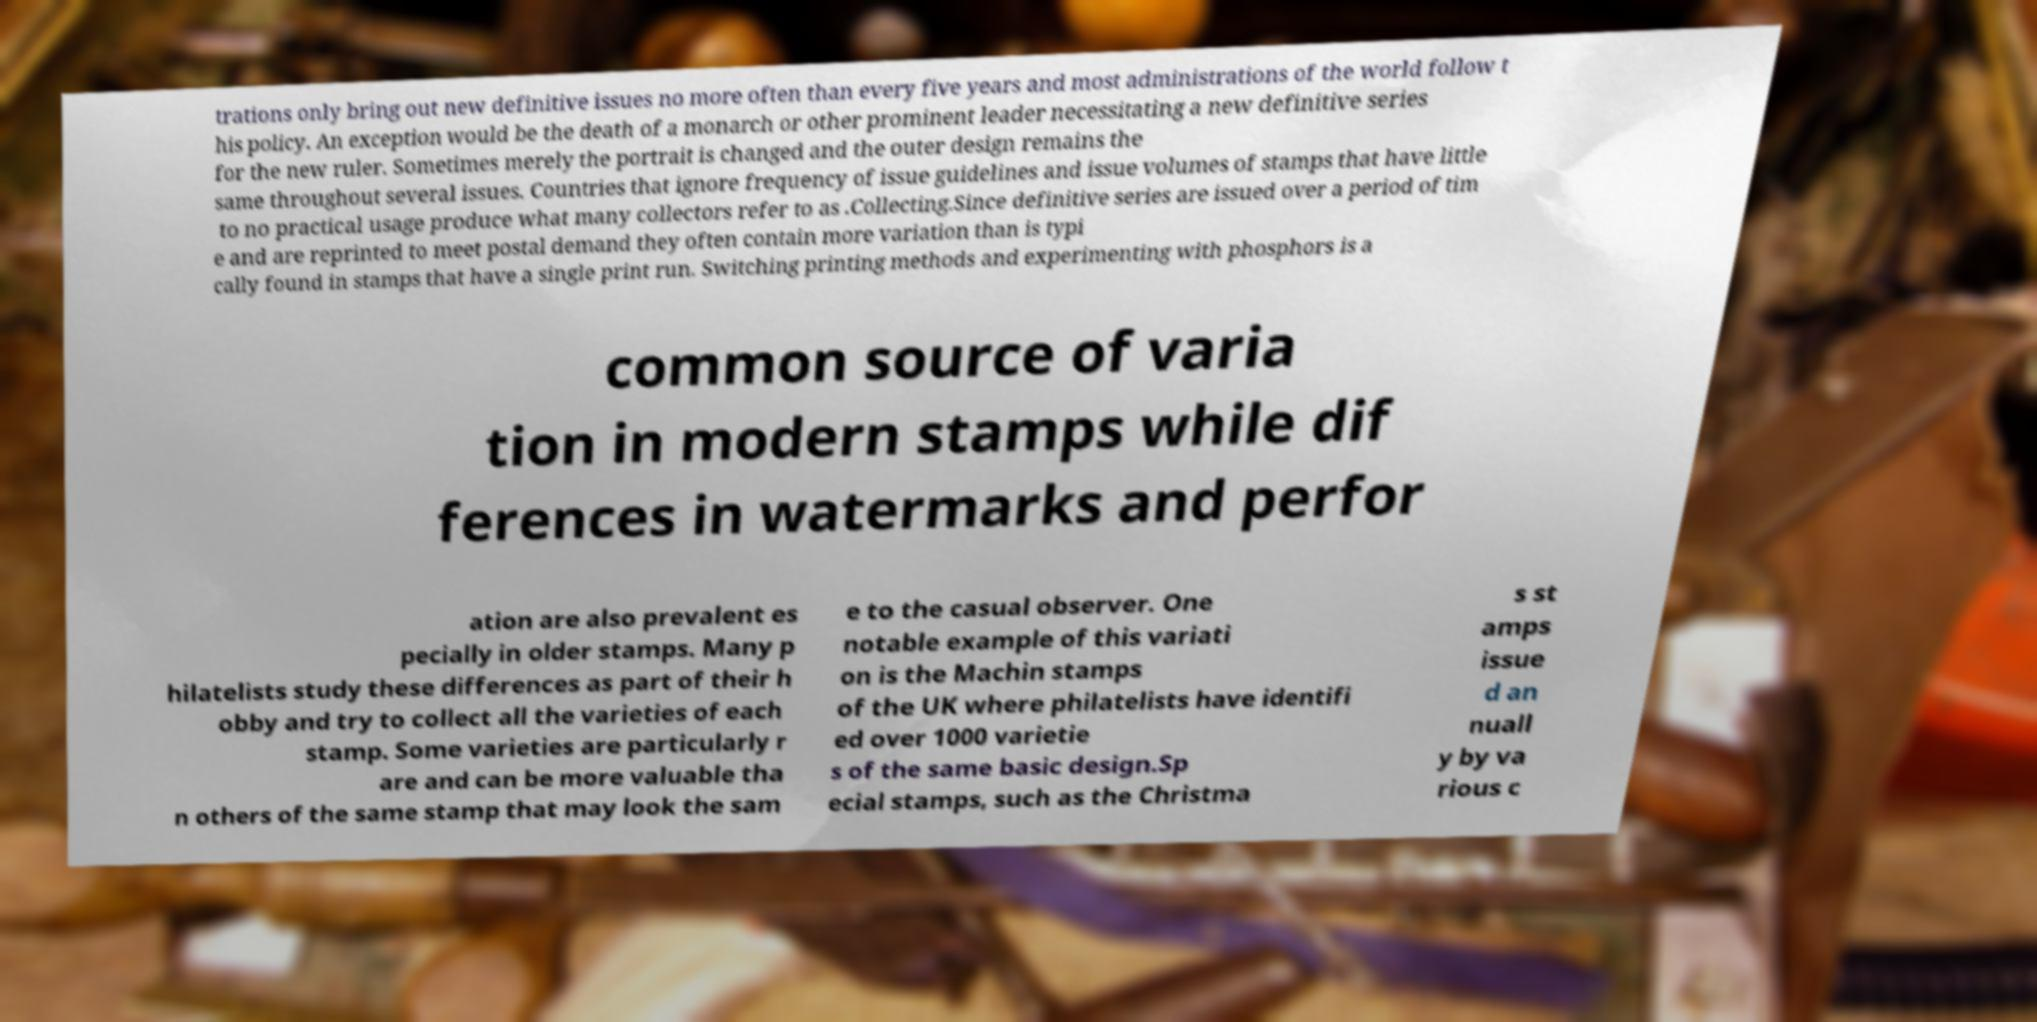Please identify and transcribe the text found in this image. trations only bring out new definitive issues no more often than every five years and most administrations of the world follow t his policy. An exception would be the death of a monarch or other prominent leader necessitating a new definitive series for the new ruler. Sometimes merely the portrait is changed and the outer design remains the same throughout several issues. Countries that ignore frequency of issue guidelines and issue volumes of stamps that have little to no practical usage produce what many collectors refer to as .Collecting.Since definitive series are issued over a period of tim e and are reprinted to meet postal demand they often contain more variation than is typi cally found in stamps that have a single print run. Switching printing methods and experimenting with phosphors is a common source of varia tion in modern stamps while dif ferences in watermarks and perfor ation are also prevalent es pecially in older stamps. Many p hilatelists study these differences as part of their h obby and try to collect all the varieties of each stamp. Some varieties are particularly r are and can be more valuable tha n others of the same stamp that may look the sam e to the casual observer. One notable example of this variati on is the Machin stamps of the UK where philatelists have identifi ed over 1000 varietie s of the same basic design.Sp ecial stamps, such as the Christma s st amps issue d an nuall y by va rious c 